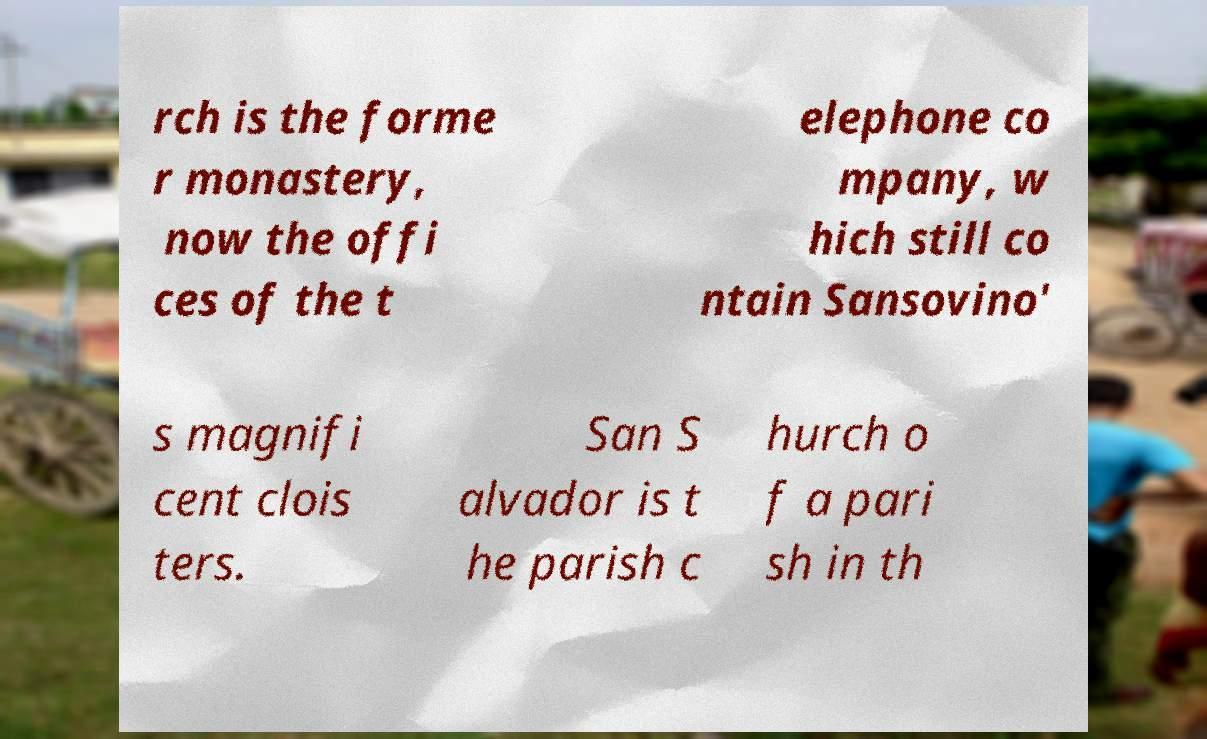What messages or text are displayed in this image? I need them in a readable, typed format. rch is the forme r monastery, now the offi ces of the t elephone co mpany, w hich still co ntain Sansovino' s magnifi cent clois ters. San S alvador is t he parish c hurch o f a pari sh in th 